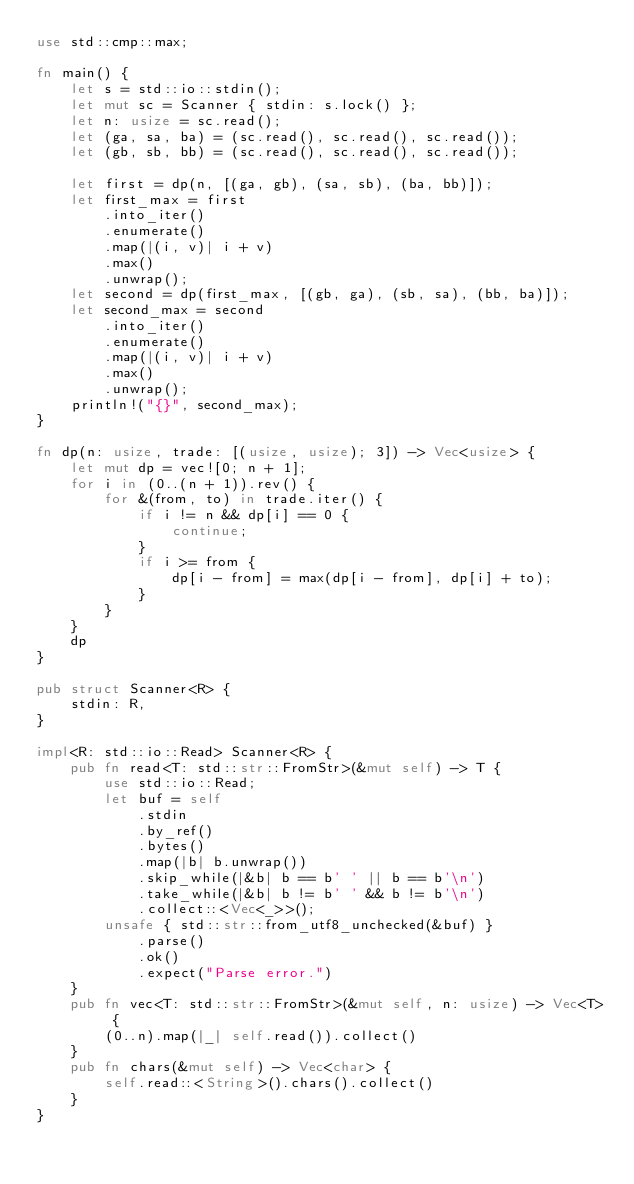<code> <loc_0><loc_0><loc_500><loc_500><_Rust_>use std::cmp::max;

fn main() {
    let s = std::io::stdin();
    let mut sc = Scanner { stdin: s.lock() };
    let n: usize = sc.read();
    let (ga, sa, ba) = (sc.read(), sc.read(), sc.read());
    let (gb, sb, bb) = (sc.read(), sc.read(), sc.read());

    let first = dp(n, [(ga, gb), (sa, sb), (ba, bb)]);
    let first_max = first
        .into_iter()
        .enumerate()
        .map(|(i, v)| i + v)
        .max()
        .unwrap();
    let second = dp(first_max, [(gb, ga), (sb, sa), (bb, ba)]);
    let second_max = second
        .into_iter()
        .enumerate()
        .map(|(i, v)| i + v)
        .max()
        .unwrap();
    println!("{}", second_max);
}

fn dp(n: usize, trade: [(usize, usize); 3]) -> Vec<usize> {
    let mut dp = vec![0; n + 1];
    for i in (0..(n + 1)).rev() {
        for &(from, to) in trade.iter() {
            if i != n && dp[i] == 0 {
                continue;
            }
            if i >= from {
                dp[i - from] = max(dp[i - from], dp[i] + to);
            }
        }
    }
    dp
}

pub struct Scanner<R> {
    stdin: R,
}

impl<R: std::io::Read> Scanner<R> {
    pub fn read<T: std::str::FromStr>(&mut self) -> T {
        use std::io::Read;
        let buf = self
            .stdin
            .by_ref()
            .bytes()
            .map(|b| b.unwrap())
            .skip_while(|&b| b == b' ' || b == b'\n')
            .take_while(|&b| b != b' ' && b != b'\n')
            .collect::<Vec<_>>();
        unsafe { std::str::from_utf8_unchecked(&buf) }
            .parse()
            .ok()
            .expect("Parse error.")
    }
    pub fn vec<T: std::str::FromStr>(&mut self, n: usize) -> Vec<T> {
        (0..n).map(|_| self.read()).collect()
    }
    pub fn chars(&mut self) -> Vec<char> {
        self.read::<String>().chars().collect()
    }
}
</code> 